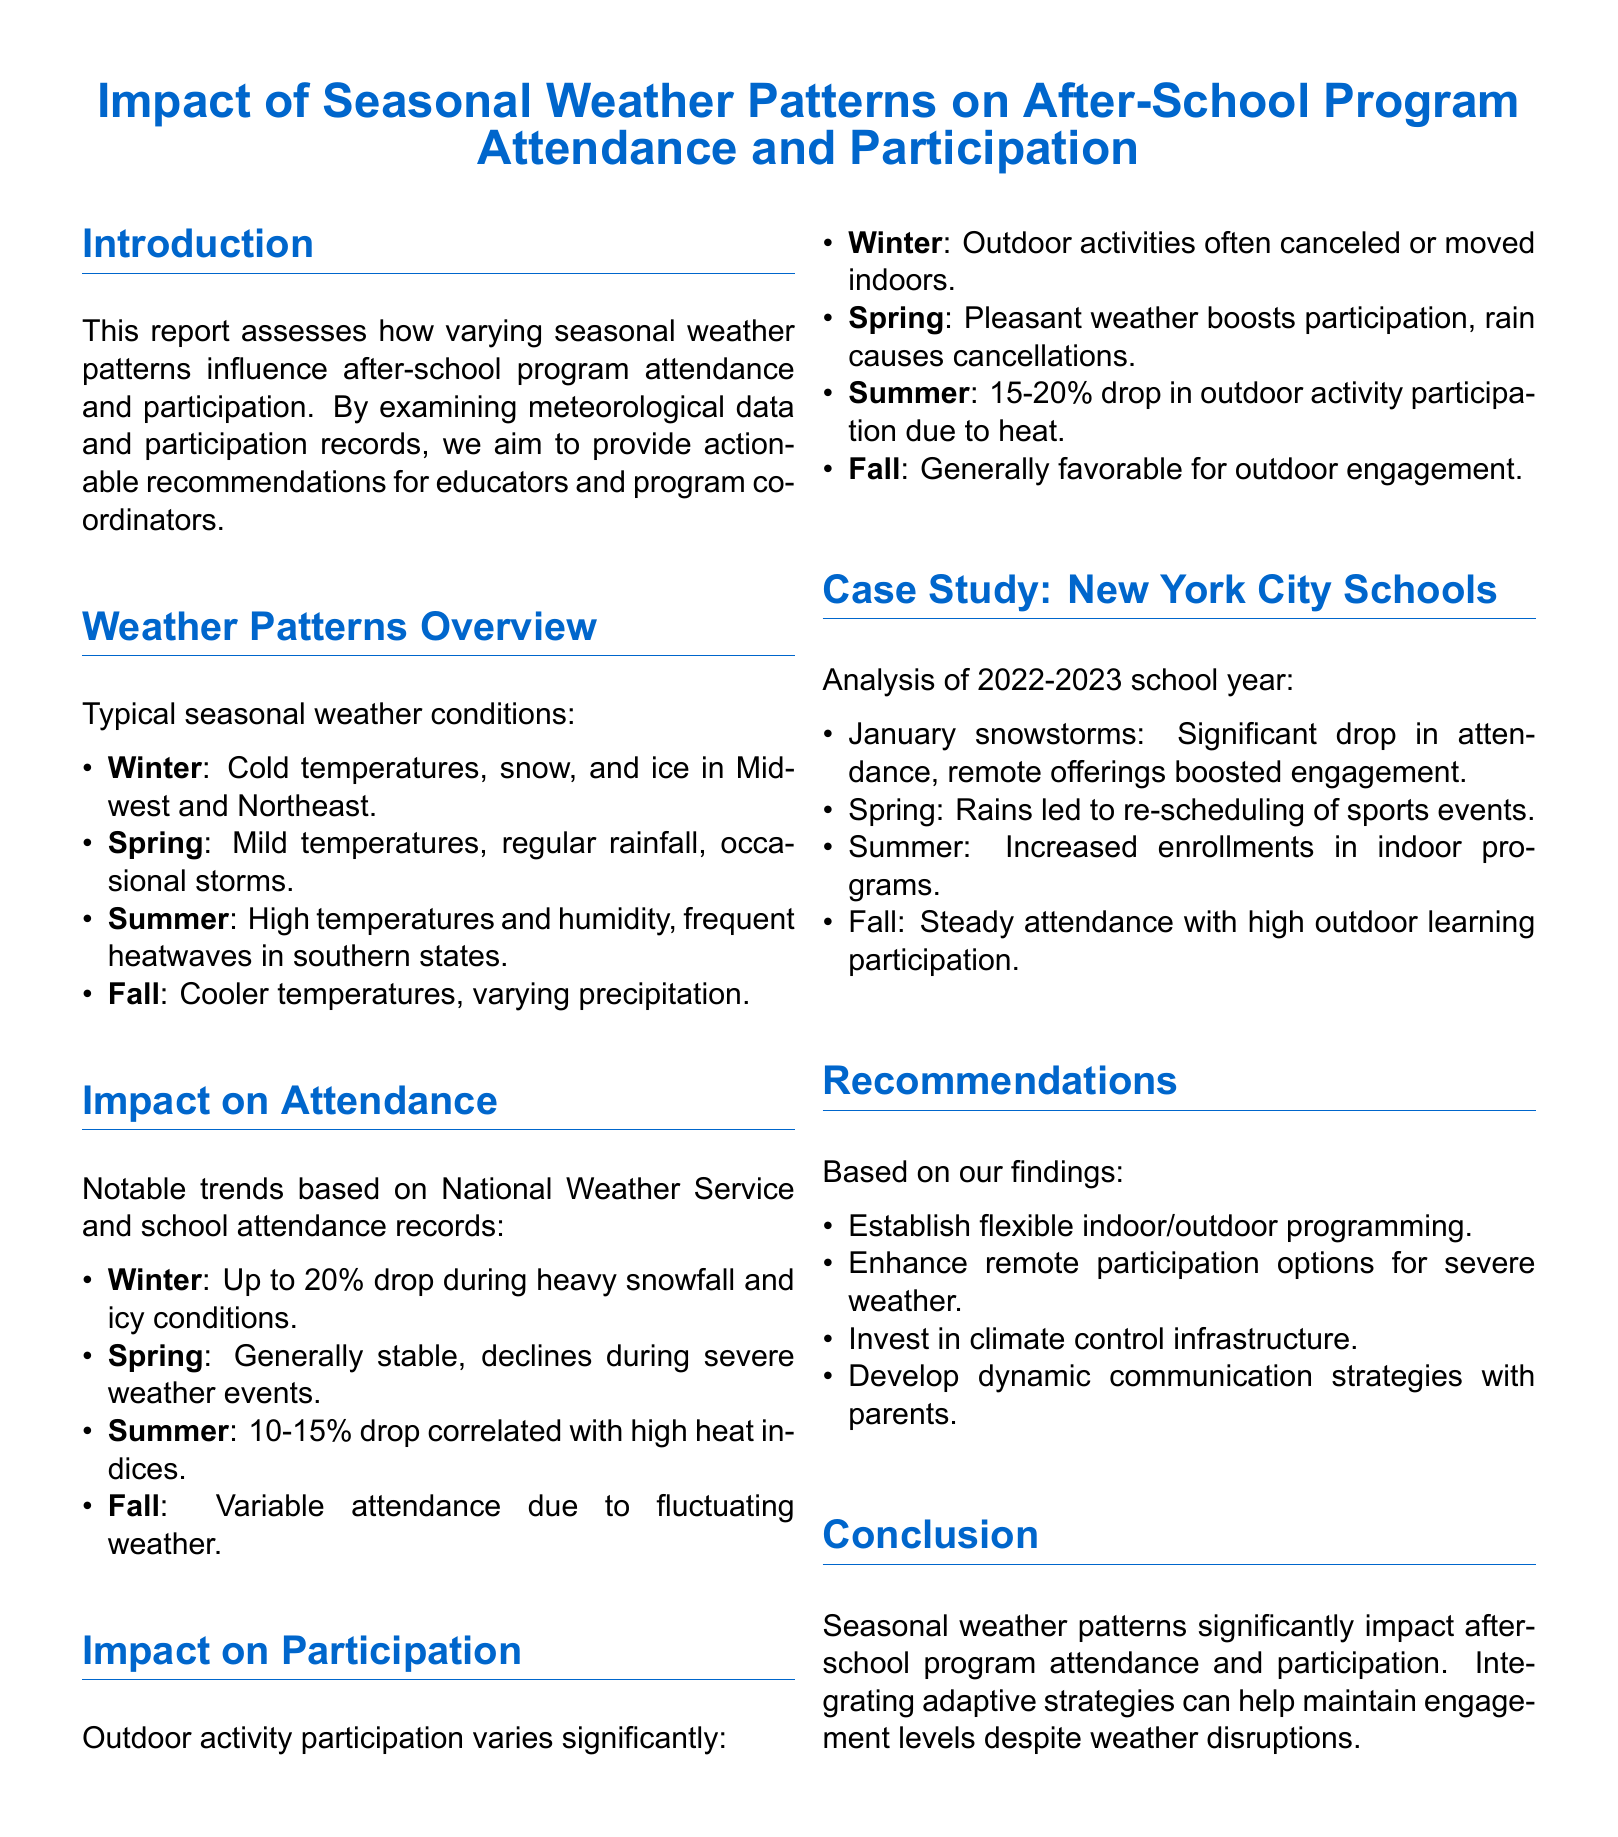What is the primary focus of this report? The report assesses how seasonal weather patterns influence attendance and participation in after-school programs.
Answer: Seasonal weather patterns What percentage drop in attendance is noted for winter during heavy snowfall? The report states that heavy snowfall can lead to a drop in attendance of up to 20%.
Answer: 20% How does spring weather generally impact program participation? Pleasant weather in spring boosts participation, although rain can cause cancellations.
Answer: Boosts participation What is the percentage drop in outdoor activity participation in summer due to heat? The report specifies a drop in outdoor activity participation of 15-20% in summer due to high heat.
Answer: 15-20% What flexible approach is recommended for after-school programming? The report suggests establishing flexible indoor/outdoor programming to accommodate weather conditions.
Answer: Flexible indoor/outdoor programming Which weather condition caused severe impacts in attendance during the analyzed case study? January snowstorms significantly lowered attendance in New York City schools during the 2022-2023 school year.
Answer: January snowstorms What communication strategy is advised for parents? The report recommends developing dynamic communication strategies with parents to keep them informed.
Answer: Dynamic communication strategies During which season did re-scheduling of sports events occur? The report mentions that spring rains led to the re-scheduling of sports events in New York City schools.
Answer: Spring What infrastructure investment is suggested to support after-school programs? The report advises investing in climate control infrastructure to ensure comfort during after-school activities.
Answer: Climate control infrastructure What was the trend in fall attendance as per the case study? The report indicates that fall attendance was steady with high outdoor learning participation.
Answer: Steady attendance 